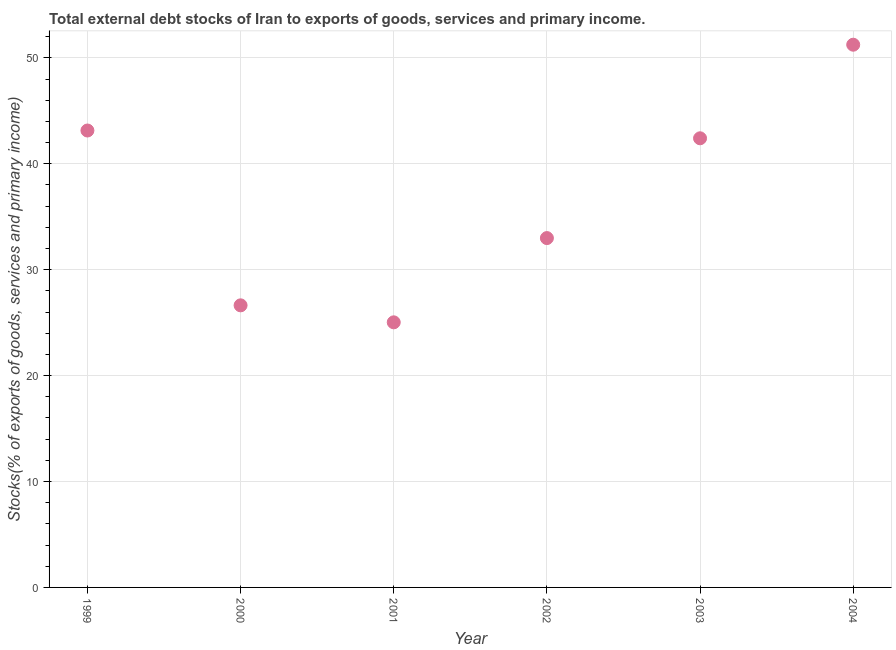What is the external debt stocks in 2000?
Your response must be concise. 26.63. Across all years, what is the maximum external debt stocks?
Offer a very short reply. 51.24. Across all years, what is the minimum external debt stocks?
Your response must be concise. 25.03. In which year was the external debt stocks maximum?
Your response must be concise. 2004. What is the sum of the external debt stocks?
Offer a terse response. 221.42. What is the difference between the external debt stocks in 1999 and 2002?
Provide a short and direct response. 10.16. What is the average external debt stocks per year?
Your answer should be compact. 36.9. What is the median external debt stocks?
Keep it short and to the point. 37.69. Do a majority of the years between 2000 and 2004 (inclusive) have external debt stocks greater than 26 %?
Your answer should be compact. Yes. What is the ratio of the external debt stocks in 2003 to that in 2004?
Offer a terse response. 0.83. Is the difference between the external debt stocks in 2000 and 2001 greater than the difference between any two years?
Make the answer very short. No. What is the difference between the highest and the second highest external debt stocks?
Offer a very short reply. 8.1. Is the sum of the external debt stocks in 2000 and 2003 greater than the maximum external debt stocks across all years?
Offer a terse response. Yes. What is the difference between the highest and the lowest external debt stocks?
Offer a very short reply. 26.21. In how many years, is the external debt stocks greater than the average external debt stocks taken over all years?
Your answer should be compact. 3. How many years are there in the graph?
Give a very brief answer. 6. Does the graph contain any zero values?
Offer a very short reply. No. What is the title of the graph?
Give a very brief answer. Total external debt stocks of Iran to exports of goods, services and primary income. What is the label or title of the X-axis?
Offer a very short reply. Year. What is the label or title of the Y-axis?
Give a very brief answer. Stocks(% of exports of goods, services and primary income). What is the Stocks(% of exports of goods, services and primary income) in 1999?
Your answer should be very brief. 43.14. What is the Stocks(% of exports of goods, services and primary income) in 2000?
Give a very brief answer. 26.63. What is the Stocks(% of exports of goods, services and primary income) in 2001?
Offer a very short reply. 25.03. What is the Stocks(% of exports of goods, services and primary income) in 2002?
Make the answer very short. 32.98. What is the Stocks(% of exports of goods, services and primary income) in 2003?
Offer a terse response. 42.4. What is the Stocks(% of exports of goods, services and primary income) in 2004?
Make the answer very short. 51.24. What is the difference between the Stocks(% of exports of goods, services and primary income) in 1999 and 2000?
Provide a succinct answer. 16.51. What is the difference between the Stocks(% of exports of goods, services and primary income) in 1999 and 2001?
Your answer should be compact. 18.11. What is the difference between the Stocks(% of exports of goods, services and primary income) in 1999 and 2002?
Make the answer very short. 10.16. What is the difference between the Stocks(% of exports of goods, services and primary income) in 1999 and 2003?
Keep it short and to the point. 0.73. What is the difference between the Stocks(% of exports of goods, services and primary income) in 1999 and 2004?
Your answer should be compact. -8.1. What is the difference between the Stocks(% of exports of goods, services and primary income) in 2000 and 2001?
Keep it short and to the point. 1.6. What is the difference between the Stocks(% of exports of goods, services and primary income) in 2000 and 2002?
Make the answer very short. -6.35. What is the difference between the Stocks(% of exports of goods, services and primary income) in 2000 and 2003?
Your answer should be very brief. -15.77. What is the difference between the Stocks(% of exports of goods, services and primary income) in 2000 and 2004?
Make the answer very short. -24.61. What is the difference between the Stocks(% of exports of goods, services and primary income) in 2001 and 2002?
Provide a succinct answer. -7.95. What is the difference between the Stocks(% of exports of goods, services and primary income) in 2001 and 2003?
Your response must be concise. -17.38. What is the difference between the Stocks(% of exports of goods, services and primary income) in 2001 and 2004?
Your answer should be very brief. -26.21. What is the difference between the Stocks(% of exports of goods, services and primary income) in 2002 and 2003?
Ensure brevity in your answer.  -9.42. What is the difference between the Stocks(% of exports of goods, services and primary income) in 2002 and 2004?
Offer a terse response. -18.26. What is the difference between the Stocks(% of exports of goods, services and primary income) in 2003 and 2004?
Your answer should be compact. -8.84. What is the ratio of the Stocks(% of exports of goods, services and primary income) in 1999 to that in 2000?
Provide a short and direct response. 1.62. What is the ratio of the Stocks(% of exports of goods, services and primary income) in 1999 to that in 2001?
Your answer should be compact. 1.72. What is the ratio of the Stocks(% of exports of goods, services and primary income) in 1999 to that in 2002?
Your response must be concise. 1.31. What is the ratio of the Stocks(% of exports of goods, services and primary income) in 1999 to that in 2003?
Provide a succinct answer. 1.02. What is the ratio of the Stocks(% of exports of goods, services and primary income) in 1999 to that in 2004?
Your response must be concise. 0.84. What is the ratio of the Stocks(% of exports of goods, services and primary income) in 2000 to that in 2001?
Give a very brief answer. 1.06. What is the ratio of the Stocks(% of exports of goods, services and primary income) in 2000 to that in 2002?
Your answer should be compact. 0.81. What is the ratio of the Stocks(% of exports of goods, services and primary income) in 2000 to that in 2003?
Your answer should be very brief. 0.63. What is the ratio of the Stocks(% of exports of goods, services and primary income) in 2000 to that in 2004?
Offer a terse response. 0.52. What is the ratio of the Stocks(% of exports of goods, services and primary income) in 2001 to that in 2002?
Give a very brief answer. 0.76. What is the ratio of the Stocks(% of exports of goods, services and primary income) in 2001 to that in 2003?
Offer a very short reply. 0.59. What is the ratio of the Stocks(% of exports of goods, services and primary income) in 2001 to that in 2004?
Offer a very short reply. 0.49. What is the ratio of the Stocks(% of exports of goods, services and primary income) in 2002 to that in 2003?
Offer a terse response. 0.78. What is the ratio of the Stocks(% of exports of goods, services and primary income) in 2002 to that in 2004?
Give a very brief answer. 0.64. What is the ratio of the Stocks(% of exports of goods, services and primary income) in 2003 to that in 2004?
Offer a very short reply. 0.83. 